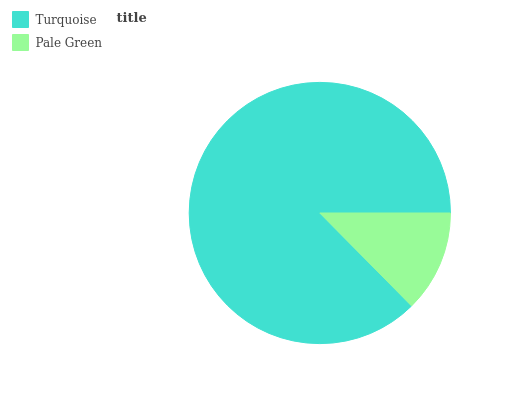Is Pale Green the minimum?
Answer yes or no. Yes. Is Turquoise the maximum?
Answer yes or no. Yes. Is Pale Green the maximum?
Answer yes or no. No. Is Turquoise greater than Pale Green?
Answer yes or no. Yes. Is Pale Green less than Turquoise?
Answer yes or no. Yes. Is Pale Green greater than Turquoise?
Answer yes or no. No. Is Turquoise less than Pale Green?
Answer yes or no. No. Is Turquoise the high median?
Answer yes or no. Yes. Is Pale Green the low median?
Answer yes or no. Yes. Is Pale Green the high median?
Answer yes or no. No. Is Turquoise the low median?
Answer yes or no. No. 